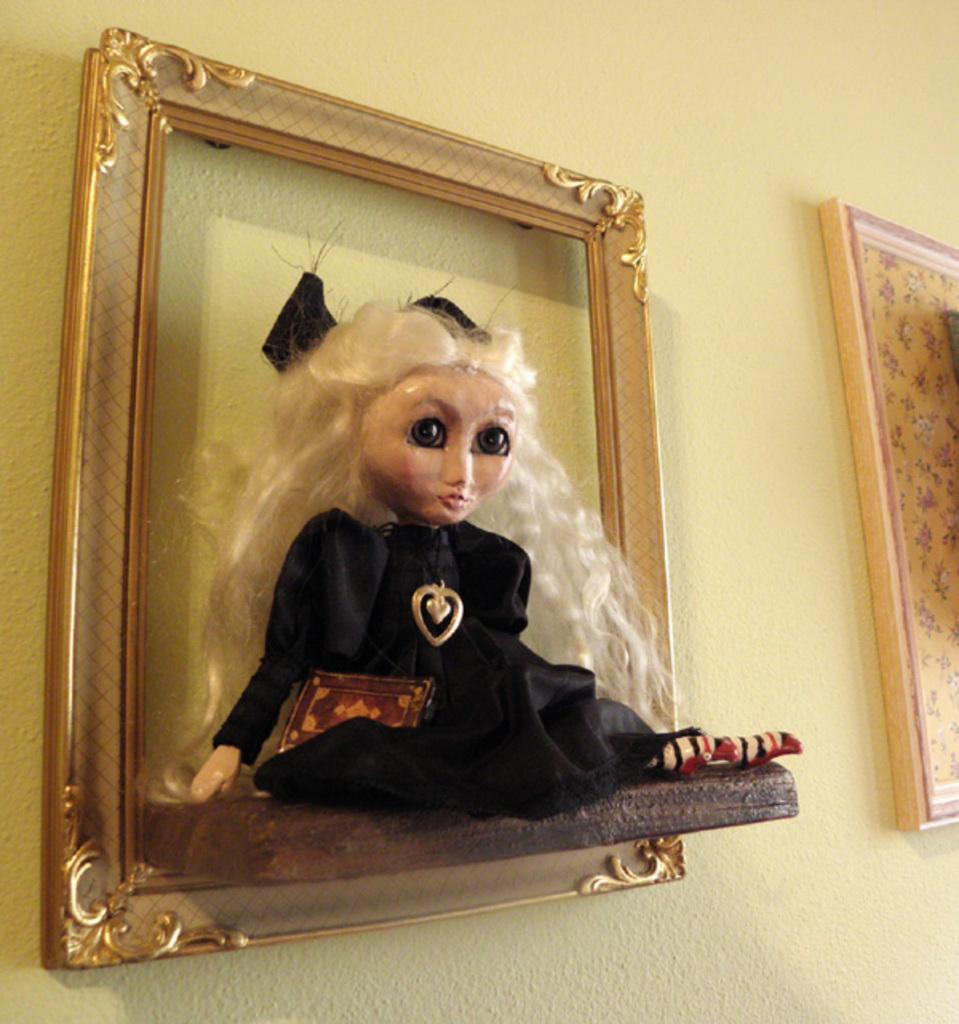What can be seen in the image that is related to framing or displaying items? There are frames in the image. What is placed on the wall in the image? There is a decor placed on the wall in the image. What type of texture can be seen on the boat in the image? There is no boat present in the image, so it is not possible to determine the texture of a boat. 